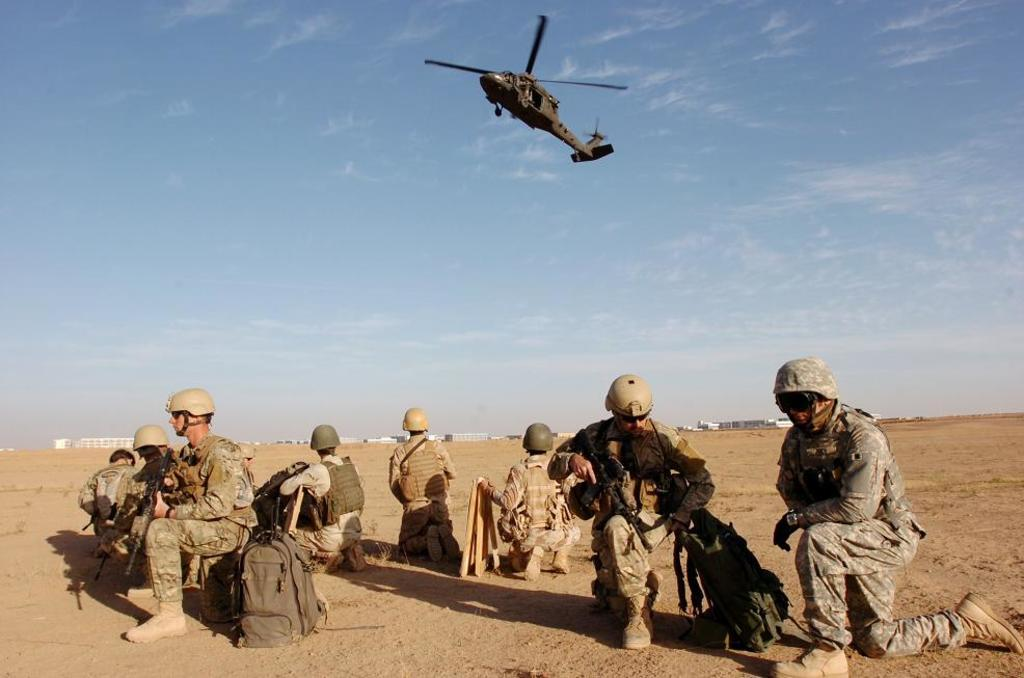What type of people can be seen in the image? There are army people in the image. What objects are associated with the army people? Weapons are present in the image. What is on the ground near the army people? Bags are on the ground in the image. What can be seen at the top of the image? There is a helicopter at the top of the image. What is visible in the sky in the image? The sky is visible in the image, and there are clouds in the sky. Where is the shelf located in the image? There is no shelf present in the image. Can you see any bats flying in the sky in the image? There are no bats visible in the image; only clouds and the helicopter can be seen in the sky. 